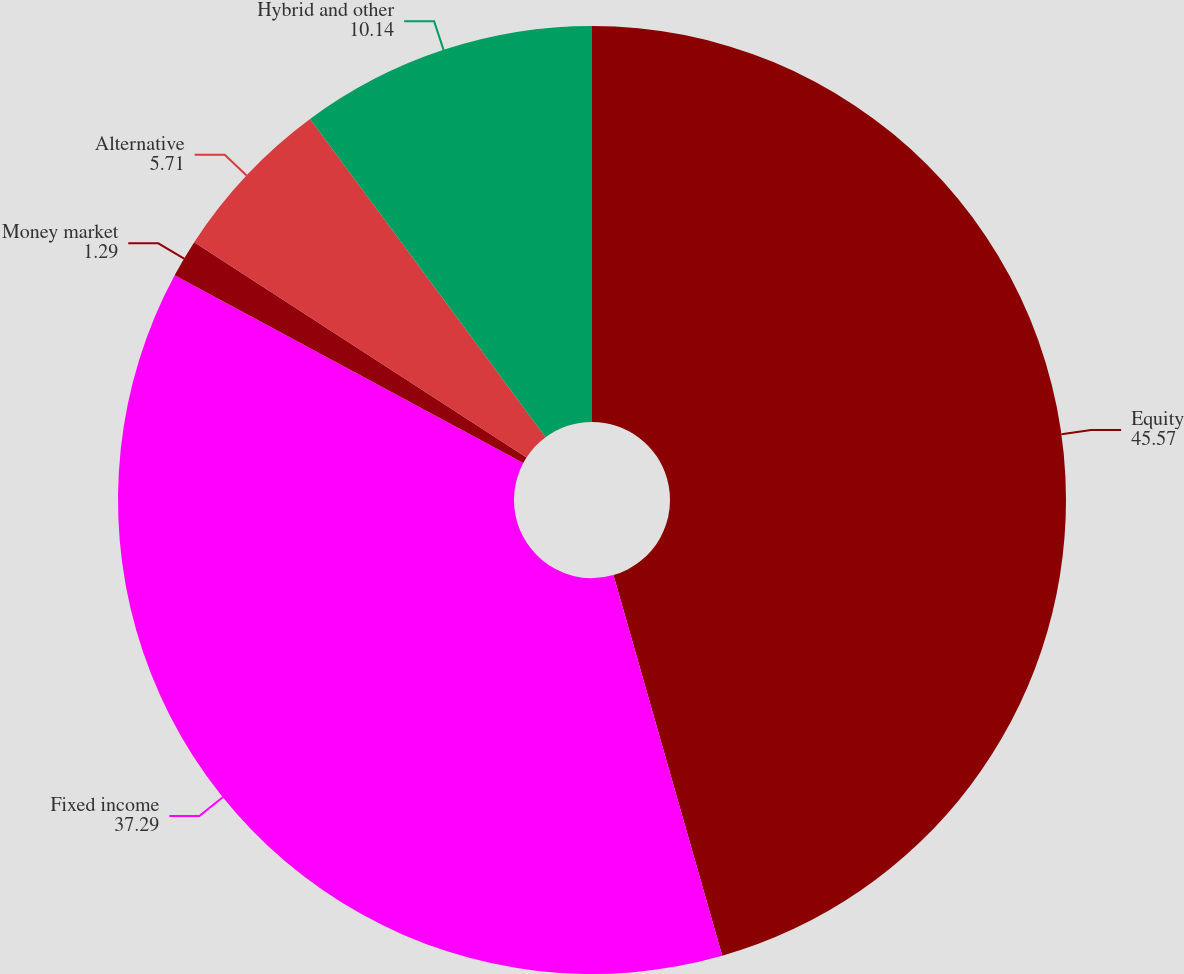<chart> <loc_0><loc_0><loc_500><loc_500><pie_chart><fcel>Equity<fcel>Fixed income<fcel>Money market<fcel>Alternative<fcel>Hybrid and other<nl><fcel>45.57%<fcel>37.29%<fcel>1.29%<fcel>5.71%<fcel>10.14%<nl></chart> 